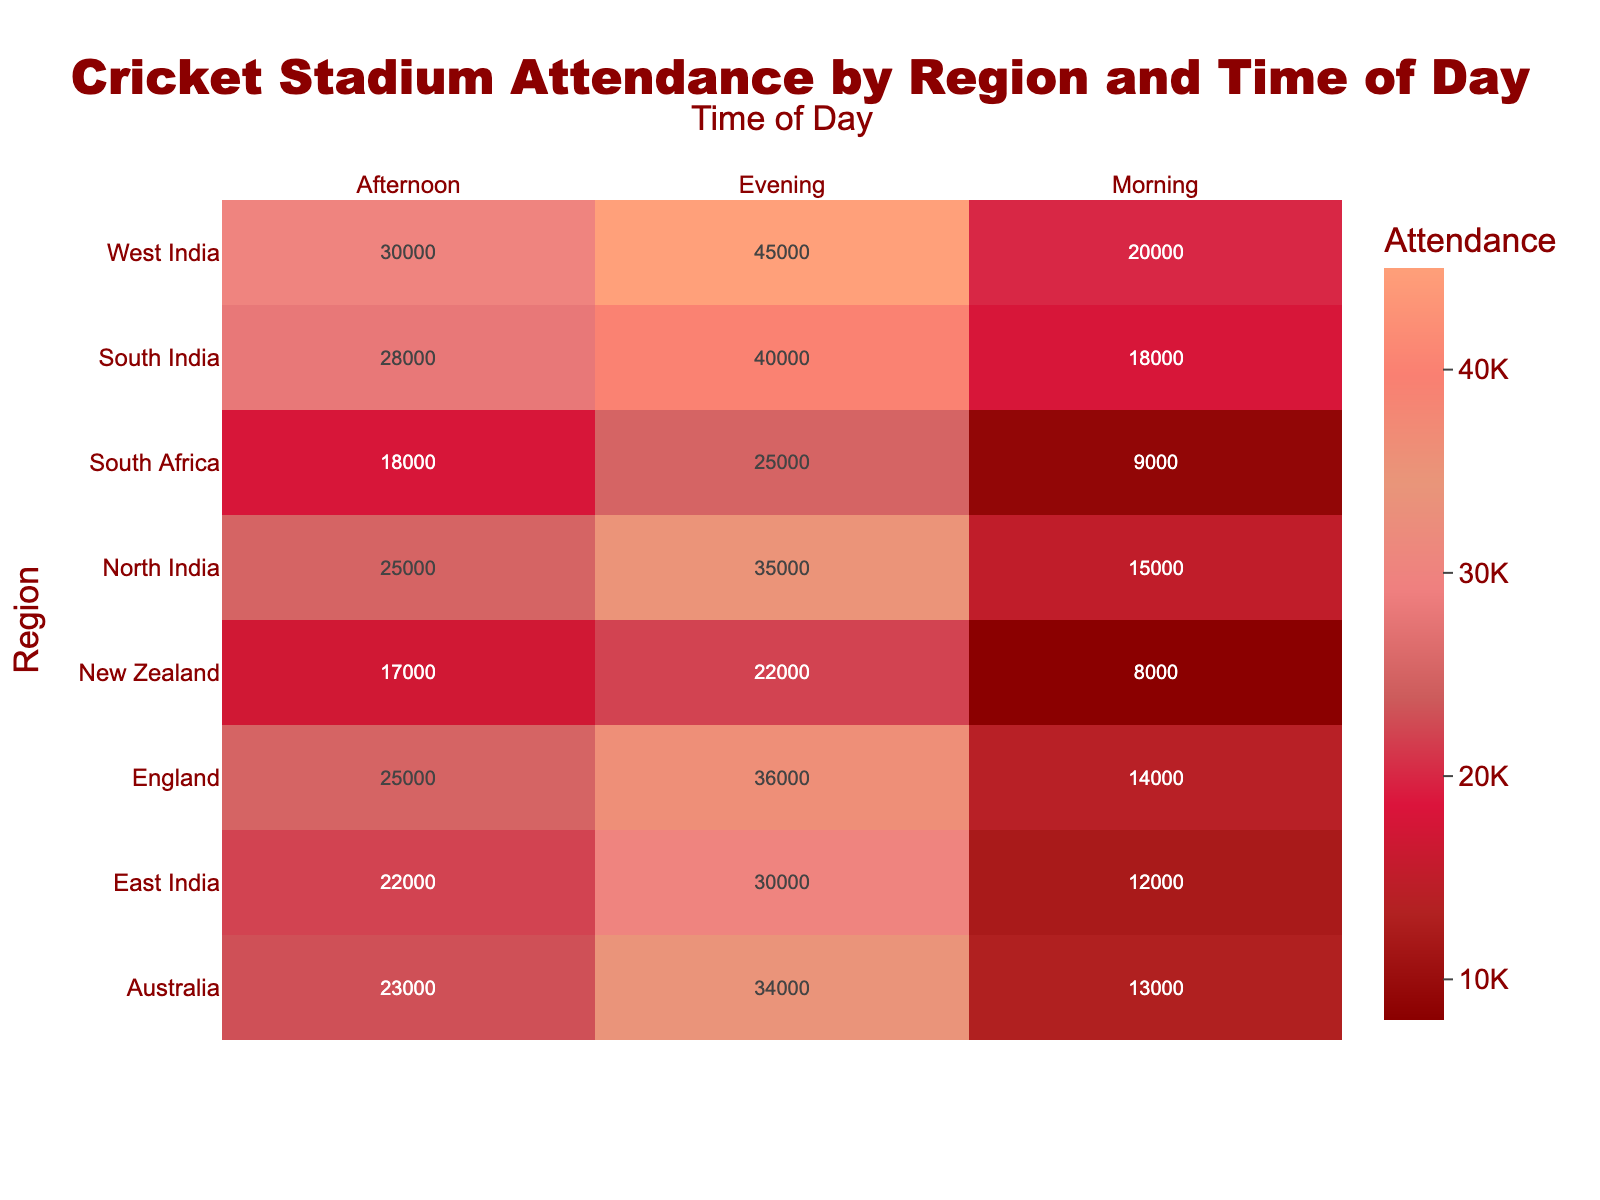What's the title of the heatmap? The title is usually displayed prominently at the top of the figure. In this case, the title reads "Cricket Stadium Attendance by Region and Time of Day"
Answer: Cricket Stadium Attendance by Region and Time of Day Which region has the highest evening attendance? To find this, we look at the evening column and find the highest value. The highest value in the evening is 45000, which is in West India.
Answer: West India What is the total attendance in South India? Sum the values for South India across all times of day: 18000 (Morning) + 28000 (Afternoon) + 40000 (Evening) = 86000
Answer: 86000 Compare the morning attendance between England and South Africa. Which is higher and by how much? Morning attendance for England is 14000 and for South Africa is 9000. Subtract South Africa's attendance from England's: 14000 - 9000 = 5000
Answer: England by 5000 Which time of day generally has the highest attendance across all regions? Look at each time of day column (Morning, Afternoon, Evening) and find which column has the highest values for most regions. The evening consistently has the highest values compared to morning and afternoon.
Answer: Evening What is the average attendance for Australia across all times of the day? Add the attendances for Australia and divide by the number of time periods: (13000 + 23000 + 34000) / 3 = 23333.33
Answer: 23333.33 How does New Zealand's afternoon attendance compare to the evening attendance in South Africa? New Zealand's afternoon attendance is 17000 and South Africa's evening attendance is 25000. South Africa's evening attendance is higher by 8000 (25000 - 17000).
Answer: Higher by 8000 What's the attendance difference between North India in the afternoon and East India in the morning? Subtract East India's morning attendance from North India's afternoon attendance: 25000 - 12000 = 13000
Answer: 13000 How does the attendance in the afternoon in England compare to the attendance in the evening in Australia? England's afternoon attendance is 25000 and Australia's evening attendance is 34000. Australia's evening attendance is higher by 9000 (34000 - 25000).
Answer: Higher by 9000 